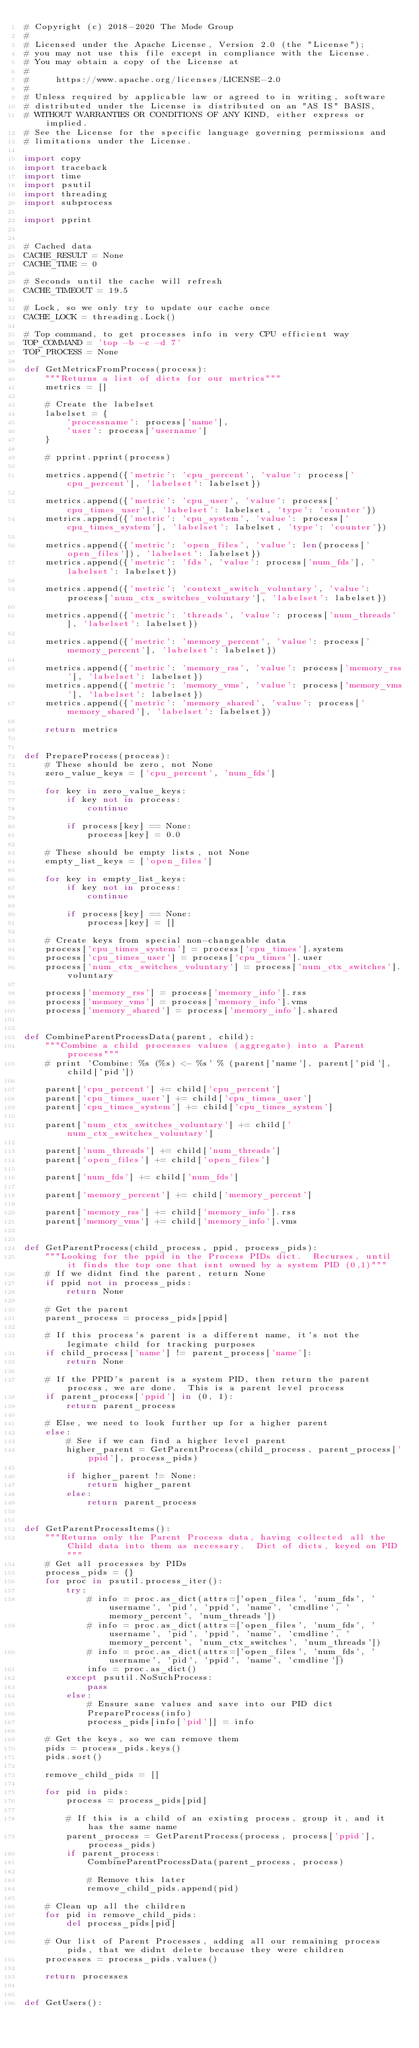Convert code to text. <code><loc_0><loc_0><loc_500><loc_500><_Python_># Copyright (c) 2018-2020 The Mode Group
#
# Licensed under the Apache License, Version 2.0 (the "License");
# you may not use this file except in compliance with the License.
# You may obtain a copy of the License at
#
#     https://www.apache.org/licenses/LICENSE-2.0
#
# Unless required by applicable law or agreed to in writing, software
# distributed under the License is distributed on an "AS IS" BASIS,
# WITHOUT WARRANTIES OR CONDITIONS OF ANY KIND, either express or implied.
# See the License for the specific language governing permissions and
# limitations under the License.

import copy
import traceback
import time
import psutil
import threading
import subprocess

import pprint


# Cached data
CACHE_RESULT = None
CACHE_TIME = 0

# Seconds until the cache will refresh
CACHE_TIMEOUT = 19.5

# Lock, so we only try to update our cache once
CACHE_LOCK = threading.Lock()

# Top command, to get processes info in very CPU efficient way
TOP_COMMAND = 'top -b -c -d 7'
TOP_PROCESS = None

def GetMetricsFromProcess(process):
    """Returns a list of dicts for our metrics"""
    metrics = []

    # Create the labelset
    labelset = {
        'processname': process['name'],
        'user': process['username']
    }

    # pprint.pprint(process)

    metrics.append({'metric': 'cpu_percent', 'value': process['cpu_percent'], 'labelset': labelset})

    metrics.append({'metric': 'cpu_user', 'value': process['cpu_times_user'], 'labelset': labelset, 'type': 'counter'})
    metrics.append({'metric': 'cpu_system', 'value': process['cpu_times_system'], 'labelset': labelset, 'type': 'counter'})

    metrics.append({'metric': 'open_files', 'value': len(process['open_files']), 'labelset': labelset})
    metrics.append({'metric': 'fds', 'value': process['num_fds'], 'labelset': labelset})

    metrics.append({'metric': 'context_switch_voluntary', 'value': process['num_ctx_switches_voluntary'], 'labelset': labelset})

    metrics.append({'metric': 'threads', 'value': process['num_threads'], 'labelset': labelset})

    metrics.append({'metric': 'memory_percent', 'value': process['memory_percent'], 'labelset': labelset})

    metrics.append({'metric': 'memory_rss', 'value': process['memory_rss'], 'labelset': labelset})
    metrics.append({'metric': 'memory_vms', 'value': process['memory_vms'], 'labelset': labelset})
    metrics.append({'metric': 'memory_shared', 'value': process['memory_shared'], 'labelset': labelset})

    return metrics


def PrepareProcess(process):
    # These should be zero, not None
    zero_value_keys = ['cpu_percent', 'num_fds']

    for key in zero_value_keys:
        if key not in process:
            continue

        if process[key] == None:
            process[key] = 0.0

    # These should be empty lists, not None
    empty_list_keys = ['open_files']

    for key in empty_list_keys:
        if key not in process:
            continue

        if process[key] == None:
            process[key] = []

    # Create keys from special non-changeable data
    process['cpu_times_system'] = process['cpu_times'].system
    process['cpu_times_user'] = process['cpu_times'].user
    process['num_ctx_switches_voluntary'] = process['num_ctx_switches'].voluntary

    process['memory_rss'] = process['memory_info'].rss
    process['memory_vms'] = process['memory_info'].vms
    process['memory_shared'] = process['memory_info'].shared


def CombineParentProcessData(parent, child):
    """Combine a child processes values (aggregate) into a Parent process"""
    # print 'Combine: %s (%s) <- %s' % (parent['name'], parent['pid'], child['pid'])

    parent['cpu_percent'] += child['cpu_percent']
    parent['cpu_times_user'] += child['cpu_times_user']
    parent['cpu_times_system'] += child['cpu_times_system']

    parent['num_ctx_switches_voluntary'] += child['num_ctx_switches_voluntary']

    parent['num_threads'] += child['num_threads']
    parent['open_files'] += child['open_files']

    parent['num_fds'] += child['num_fds']

    parent['memory_percent'] += child['memory_percent']

    parent['memory_rss'] += child['memory_info'].rss
    parent['memory_vms'] += child['memory_info'].vms


def GetParentProcess(child_process, ppid, process_pids):
    """Looking for the ppid in the Process PIDs dict.  Recurses, until it finds the top one that isnt owned by a system PID (0,1)"""
    # If we didnt find the parent, return None
    if ppid not in process_pids:
        return None

    # Get the parent
    parent_process = process_pids[ppid]

    # If this process's parent is a different name, it's not the legimate child for tracking purposes
    if child_process['name'] != parent_process['name']:
        return None

    # If the PPID's parent is a system PID, then return the parent process, we are done.  This is a parent level process
    if parent_process['ppid'] in (0, 1):
        return parent_process

    # Else, we need to look further up for a higher parent
    else:
        # See if we can find a higher level parent
        higher_parent = GetParentProcess(child_process, parent_process['ppid'], process_pids)

        if higher_parent != None:
            return higher_parent
        else:
            return parent_process


def GetParentProcessItems():
    """Returns only the Parent Process data, having collected all the Child data into them as necessary.  Dict of dicts, keyed on PID"""
    # Get all processes by PIDs
    process_pids = {}
    for proc in psutil.process_iter():
        try:
            # info = proc.as_dict(attrs=['open_files', 'num_fds', 'username', 'pid', 'ppid', 'name', 'cmdline', 'memory_percent', 'num_threads'])
            # info = proc.as_dict(attrs=['open_files', 'num_fds', 'username', 'pid', 'ppid', 'name', 'cmdline', 'memory_percent', 'num_ctx_switches', 'num_threads'])
            # info = proc.as_dict(attrs=['open_files', 'num_fds', 'username', 'pid', 'ppid', 'name', 'cmdline'])
            info = proc.as_dict()
        except psutil.NoSuchProcess:
            pass
        else:
            # Ensure sane values and save into our PID dict
            PrepareProcess(info)
            process_pids[info['pid']] = info

    # Get the keys, so we can remove them
    pids = process_pids.keys()
    pids.sort()

    remove_child_pids = []

    for pid in pids:
        process = process_pids[pid]

        # If this is a child of an existing process, group it, and it has the same name
        parent_process = GetParentProcess(process, process['ppid'], process_pids)
        if parent_process:
            CombineParentProcessData(parent_process, process)

            # Remove this later
            remove_child_pids.append(pid)

    # Clean up all the children
    for pid in remove_child_pids:
        del process_pids[pid]

    # Our list of Parent Processes, adding all our remaining process pids, that we didnt delete because they were children
    processes = process_pids.values()

    return processes


def GetUsers():</code> 